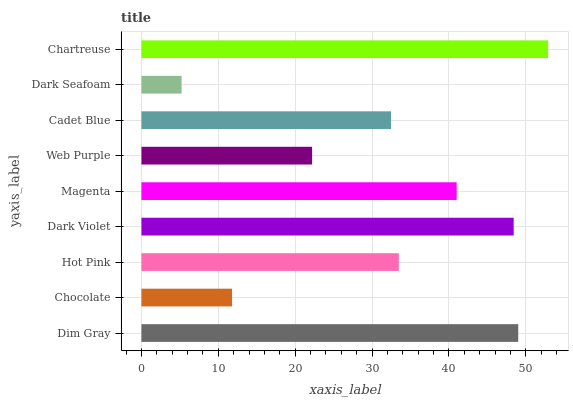Is Dark Seafoam the minimum?
Answer yes or no. Yes. Is Chartreuse the maximum?
Answer yes or no. Yes. Is Chocolate the minimum?
Answer yes or no. No. Is Chocolate the maximum?
Answer yes or no. No. Is Dim Gray greater than Chocolate?
Answer yes or no. Yes. Is Chocolate less than Dim Gray?
Answer yes or no. Yes. Is Chocolate greater than Dim Gray?
Answer yes or no. No. Is Dim Gray less than Chocolate?
Answer yes or no. No. Is Hot Pink the high median?
Answer yes or no. Yes. Is Hot Pink the low median?
Answer yes or no. Yes. Is Cadet Blue the high median?
Answer yes or no. No. Is Chartreuse the low median?
Answer yes or no. No. 